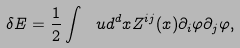Convert formula to latex. <formula><loc_0><loc_0><loc_500><loc_500>\delta E = \frac { 1 } { 2 } \int \ u d ^ { d } x Z ^ { i j } ( x ) \partial _ { i } \varphi \partial _ { j } \varphi ,</formula> 